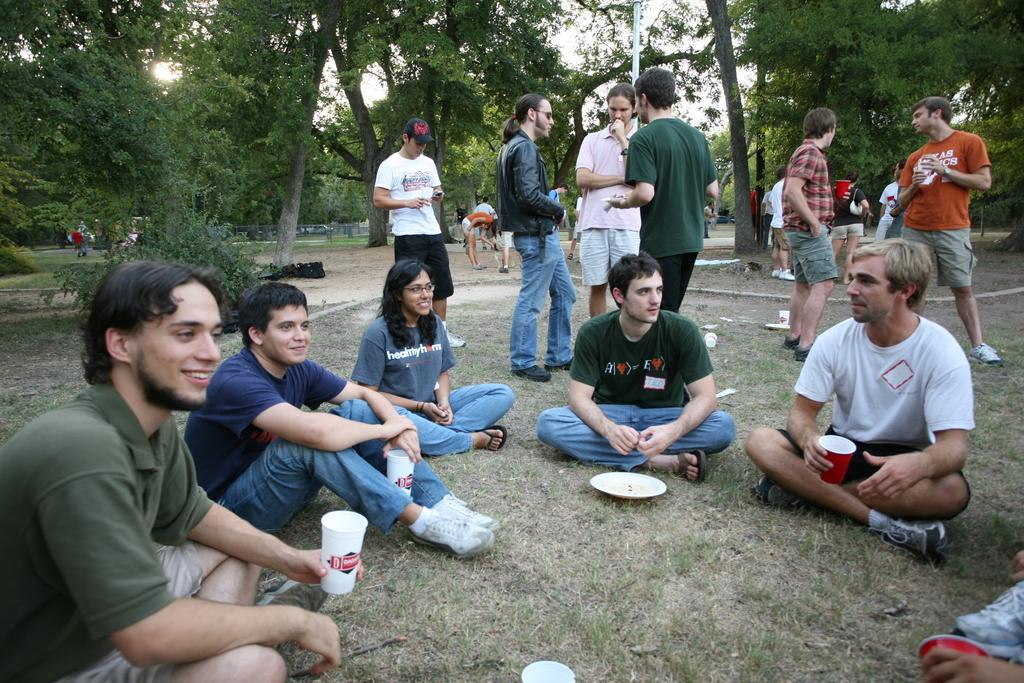What is happening in the image involving a group of people? There is a group of people in the image, with some sitting and smiling, and others standing on the ground. What objects can be seen in the image related to eating or drinking? There are plates and glasses visible in the image. What can be seen in the background of the image? There are trees and the sky visible in the background of the image. Reasoning: Let's think step by step by step in order to produce the conversation. We start by identifying the main subject in the image, which is the group of people. Then, we expand the conversation to include their actions and expressions, as well as the presence of plates and glasses. Finally, we describe the background of the image, which includes trees and the sky. Absurd Question/Answer: Can you see any ghosts interacting with the group of people in the image? There are no ghosts present in the image; it only features a group of people, plates, glasses, trees, and the sky. 